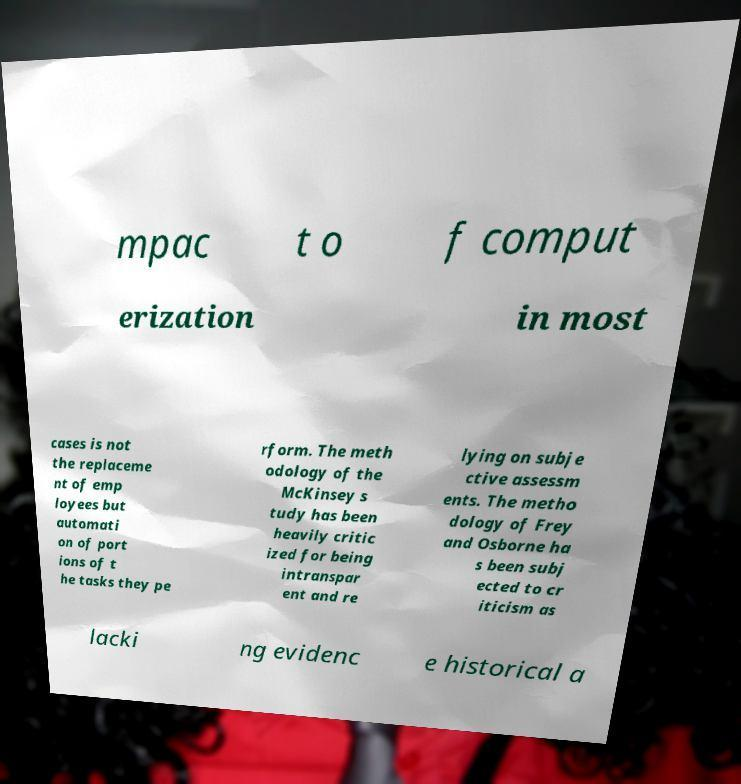Could you extract and type out the text from this image? mpac t o f comput erization in most cases is not the replaceme nt of emp loyees but automati on of port ions of t he tasks they pe rform. The meth odology of the McKinsey s tudy has been heavily critic ized for being intranspar ent and re lying on subje ctive assessm ents. The metho dology of Frey and Osborne ha s been subj ected to cr iticism as lacki ng evidenc e historical a 